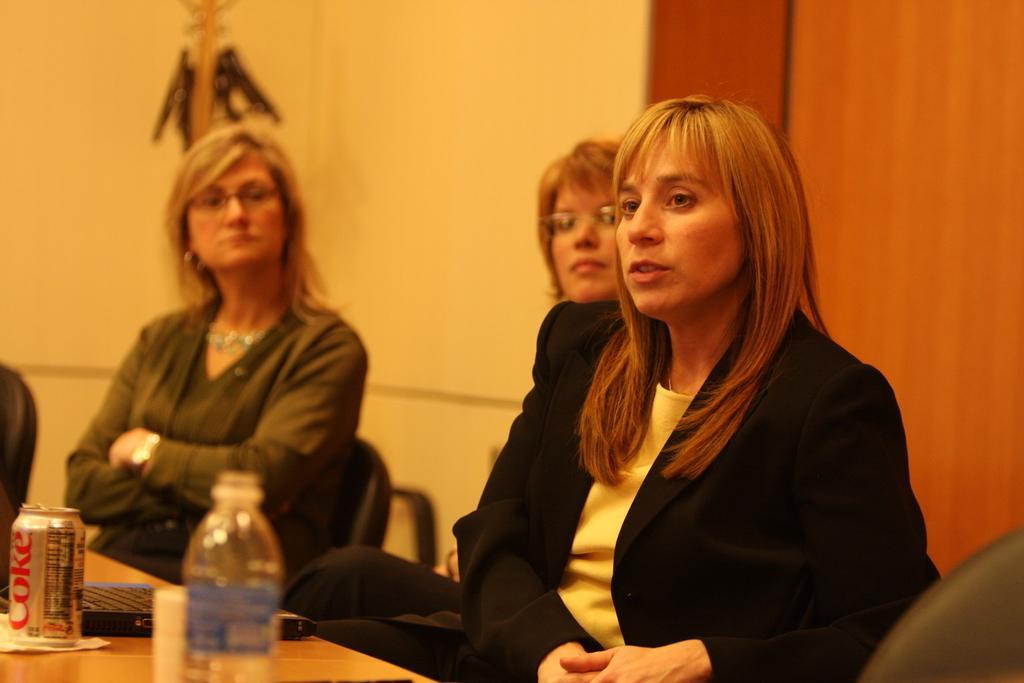In one or two sentences, can you explain what this image depicts? In this picture there are three women sitting, they have a table in front of them. There is a water bottle, beverage can and water bottle. In the background there is a wall. 